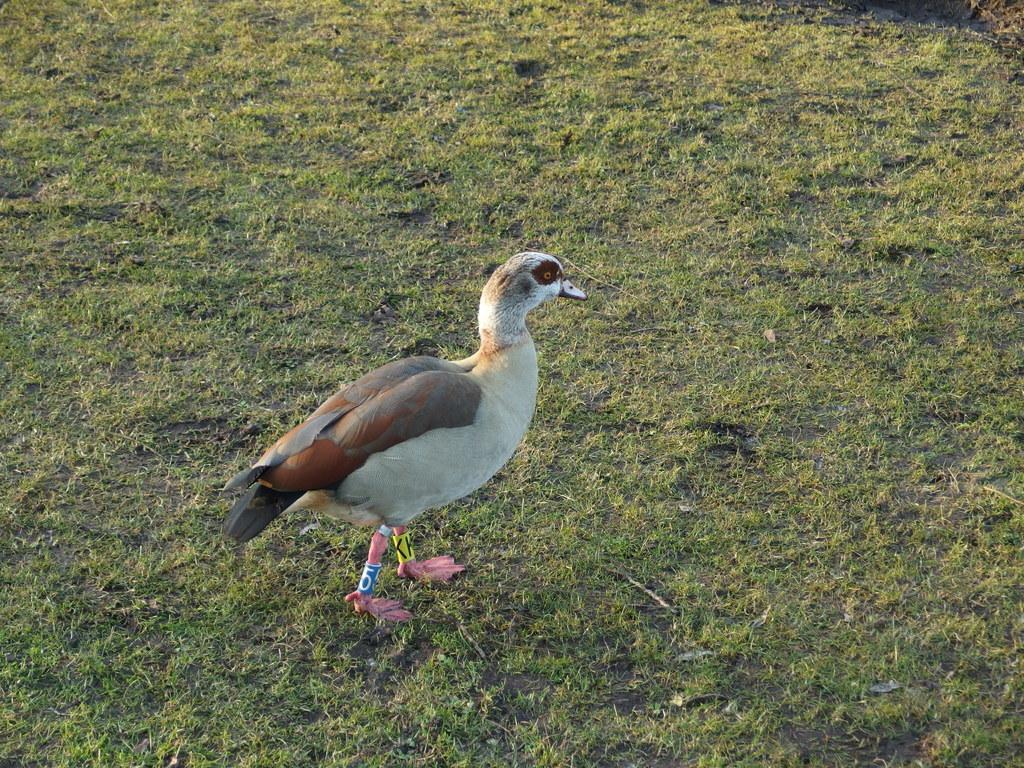What type of animal can be seen in the image? There is a bird in the image. Where is the bird located in relation to the ground? The bird is standing on the ground. What is the bird's position in the image? The bird is in the center of the image. What type of vegetation is present on the ground in the image? There is grass on the ground in the image. What type of flame can be seen on the side of the bird in the image? There is no flame present in the image, and the bird does not have a side with a flame. 